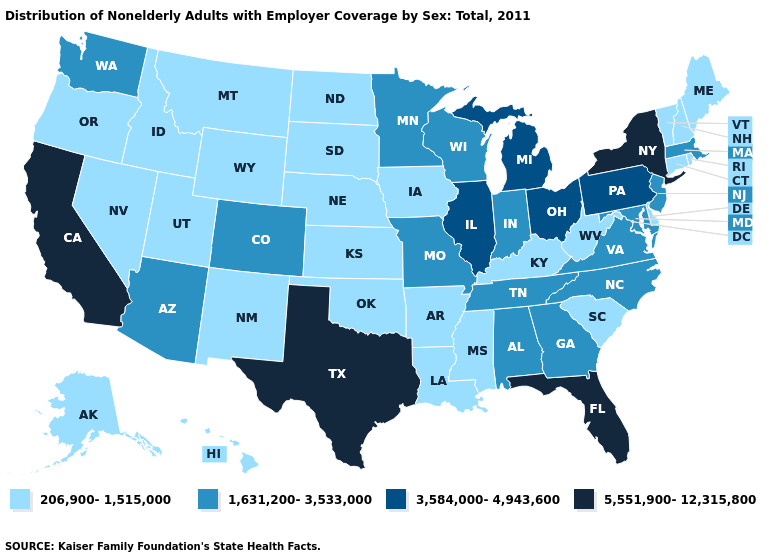What is the value of Arkansas?
Be succinct. 206,900-1,515,000. Among the states that border Massachusetts , does New York have the highest value?
Keep it brief. Yes. Does Texas have the highest value in the USA?
Quick response, please. Yes. What is the lowest value in the USA?
Short answer required. 206,900-1,515,000. What is the value of Virginia?
Give a very brief answer. 1,631,200-3,533,000. What is the value of Maine?
Quick response, please. 206,900-1,515,000. Name the states that have a value in the range 206,900-1,515,000?
Concise answer only. Alaska, Arkansas, Connecticut, Delaware, Hawaii, Idaho, Iowa, Kansas, Kentucky, Louisiana, Maine, Mississippi, Montana, Nebraska, Nevada, New Hampshire, New Mexico, North Dakota, Oklahoma, Oregon, Rhode Island, South Carolina, South Dakota, Utah, Vermont, West Virginia, Wyoming. What is the highest value in the USA?
Keep it brief. 5,551,900-12,315,800. Does Alabama have the lowest value in the USA?
Answer briefly. No. Name the states that have a value in the range 1,631,200-3,533,000?
Short answer required. Alabama, Arizona, Colorado, Georgia, Indiana, Maryland, Massachusetts, Minnesota, Missouri, New Jersey, North Carolina, Tennessee, Virginia, Washington, Wisconsin. Among the states that border Nevada , which have the highest value?
Be succinct. California. What is the highest value in the USA?
Short answer required. 5,551,900-12,315,800. What is the value of Alabama?
Keep it brief. 1,631,200-3,533,000. Does the map have missing data?
Answer briefly. No. Name the states that have a value in the range 1,631,200-3,533,000?
Keep it brief. Alabama, Arizona, Colorado, Georgia, Indiana, Maryland, Massachusetts, Minnesota, Missouri, New Jersey, North Carolina, Tennessee, Virginia, Washington, Wisconsin. 